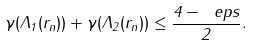<formula> <loc_0><loc_0><loc_500><loc_500>\gamma ( \Lambda _ { 1 } ( r _ { n } ) ) + \gamma ( \Lambda _ { 2 } ( r _ { n } ) ) \leq \frac { 4 - \ e p s } { 2 } .</formula> 